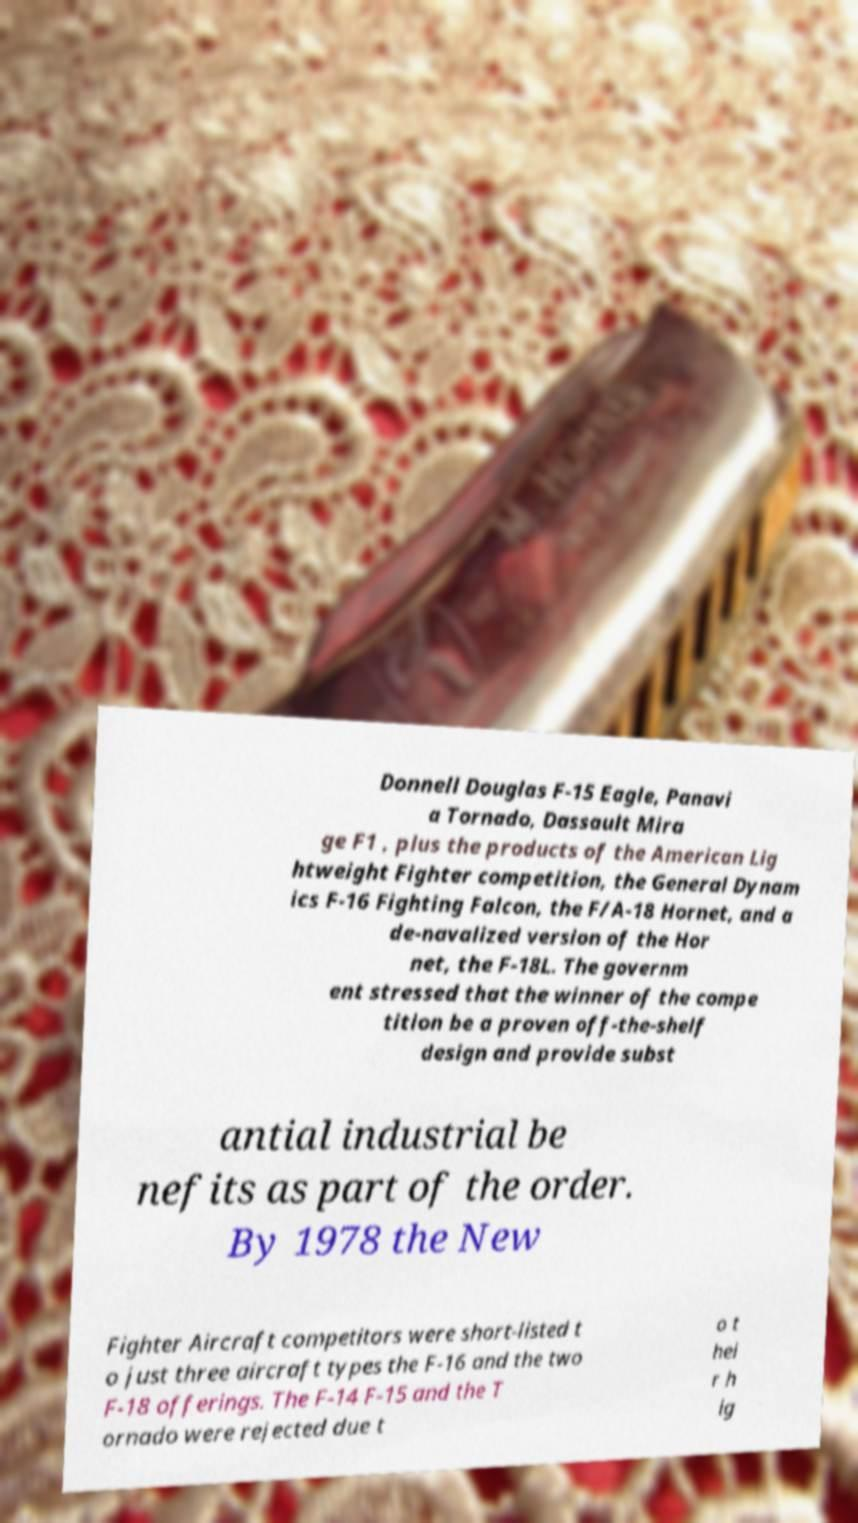Please identify and transcribe the text found in this image. Donnell Douglas F-15 Eagle, Panavi a Tornado, Dassault Mira ge F1 , plus the products of the American Lig htweight Fighter competition, the General Dynam ics F-16 Fighting Falcon, the F/A-18 Hornet, and a de-navalized version of the Hor net, the F-18L. The governm ent stressed that the winner of the compe tition be a proven off-the-shelf design and provide subst antial industrial be nefits as part of the order. By 1978 the New Fighter Aircraft competitors were short-listed t o just three aircraft types the F-16 and the two F-18 offerings. The F-14 F-15 and the T ornado were rejected due t o t hei r h ig 